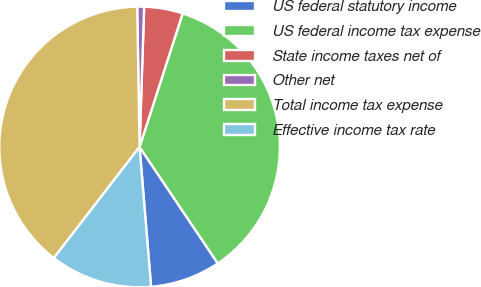Convert chart. <chart><loc_0><loc_0><loc_500><loc_500><pie_chart><fcel>US federal statutory income<fcel>US federal income tax expense<fcel>State income taxes net of<fcel>Other net<fcel>Total income tax expense<fcel>Effective income tax rate<nl><fcel>8.11%<fcel>35.61%<fcel>4.45%<fcel>0.79%<fcel>39.27%<fcel>11.77%<nl></chart> 